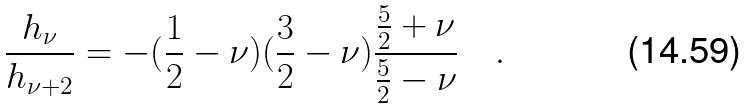<formula> <loc_0><loc_0><loc_500><loc_500>\frac { h _ { \nu } } { h _ { \nu + 2 } } = - ( \frac { 1 } { 2 } - \nu ) ( \frac { 3 } { 2 } - \nu ) \frac { \frac { 5 } { 2 } + \nu } { \frac { 5 } { 2 } - \nu } \quad .</formula> 